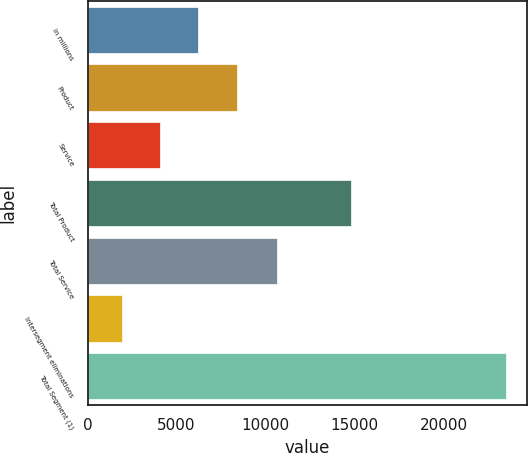<chart> <loc_0><loc_0><loc_500><loc_500><bar_chart><fcel>in millions<fcel>Product<fcel>Service<fcel>Total Product<fcel>Total Service<fcel>Intersegment eliminations<fcel>Total Segment (1)<nl><fcel>6230.8<fcel>8392.7<fcel>4068.9<fcel>14782<fcel>10651<fcel>1907<fcel>23526<nl></chart> 